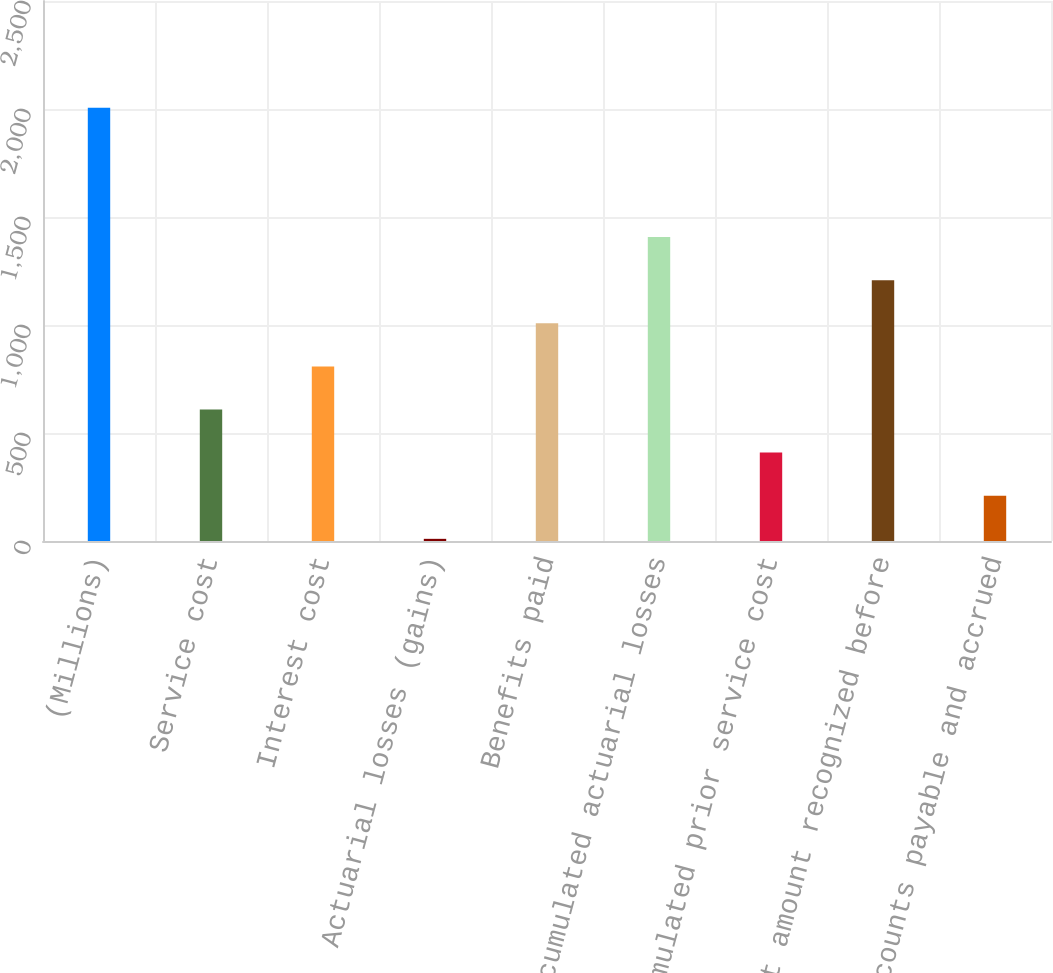Convert chart to OTSL. <chart><loc_0><loc_0><loc_500><loc_500><bar_chart><fcel>(Millions)<fcel>Service cost<fcel>Interest cost<fcel>Actuarial losses (gains)<fcel>Benefits paid<fcel>Accumulated actuarial losses<fcel>Accumulated prior service cost<fcel>Net amount recognized before<fcel>Accounts payable and accrued<nl><fcel>2006<fcel>608.8<fcel>808.4<fcel>10<fcel>1008<fcel>1407.2<fcel>409.2<fcel>1207.6<fcel>209.6<nl></chart> 